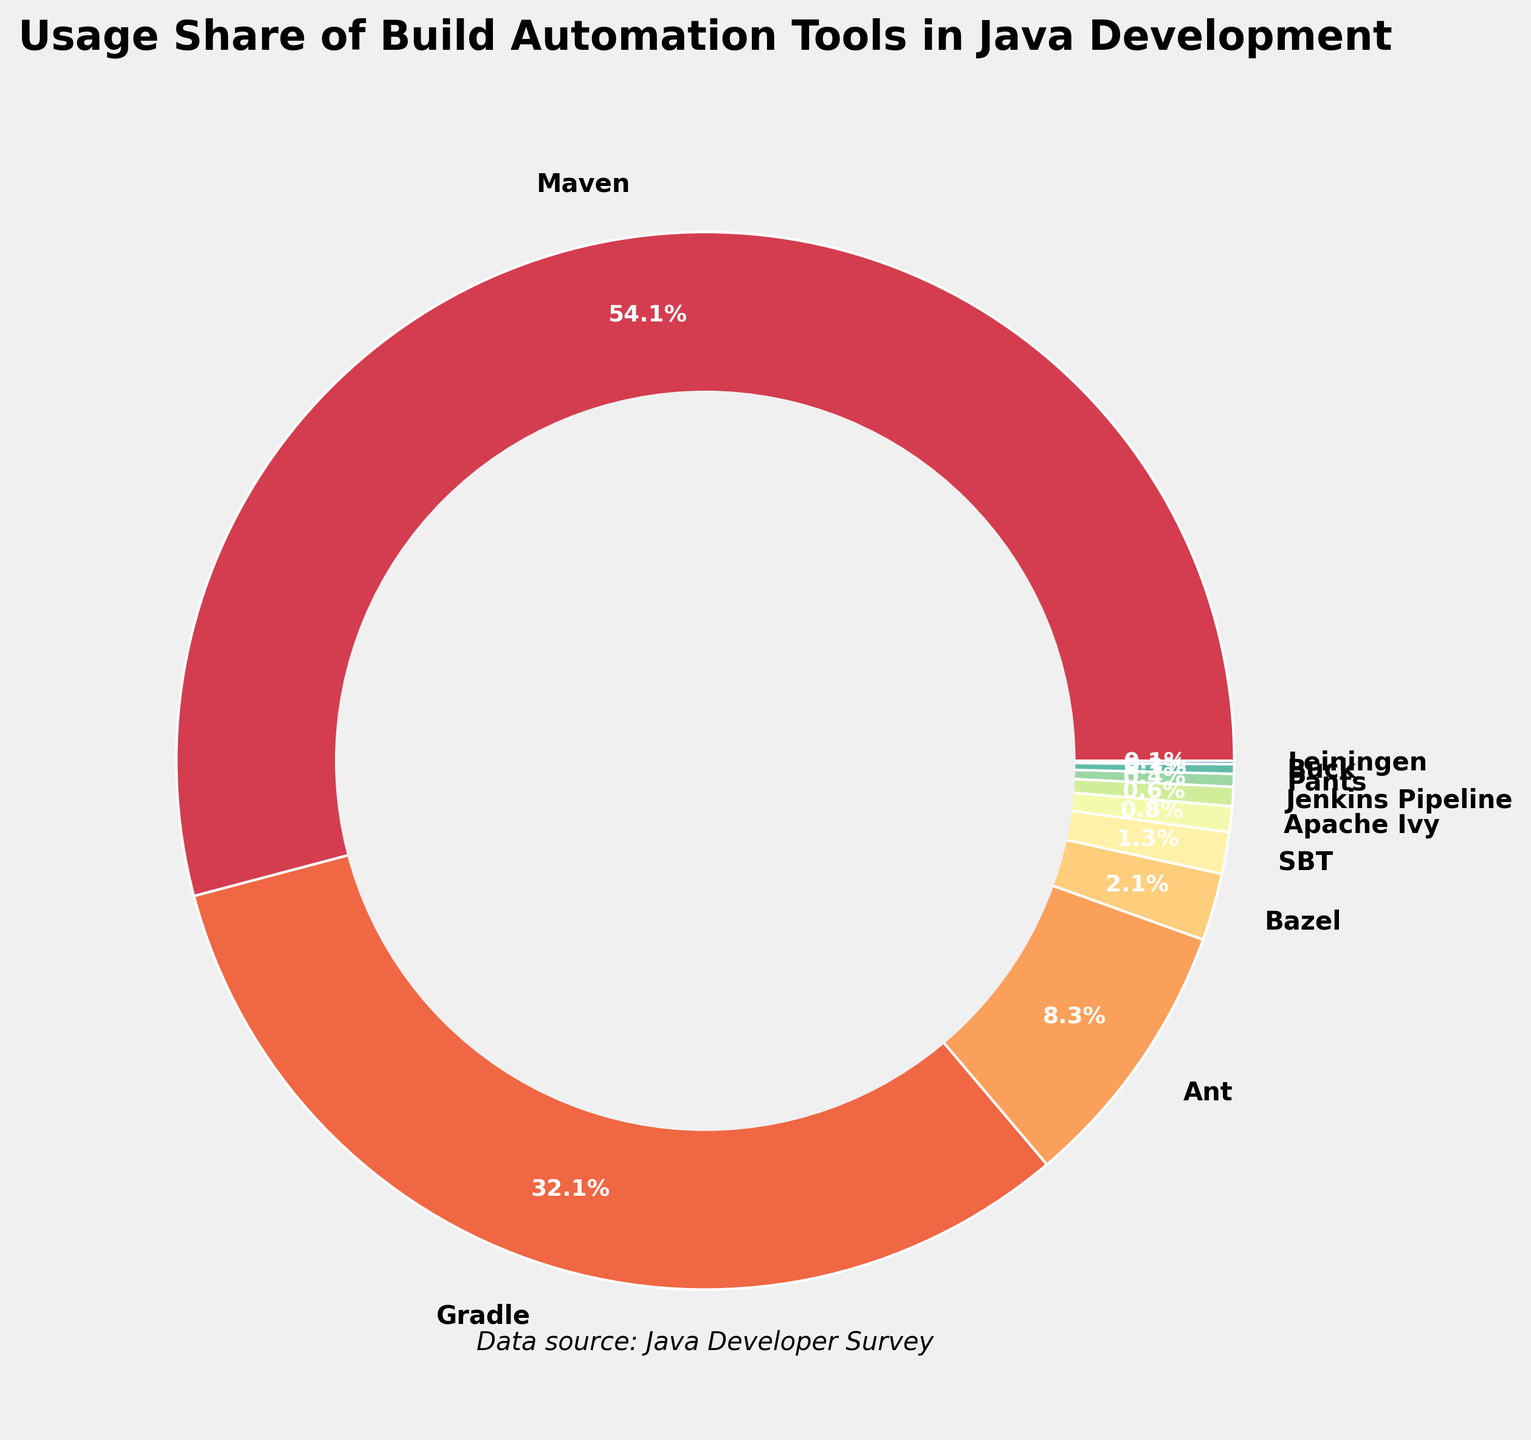What is the usage share of Maven? The pie chart shows the usage share of each build tool, and Maven's share is labeled.
Answer: 55.2% Which build tool has the second-highest usage share? By comparing the usage shares, Gradle has the second-highest share after Maven.
Answer: Gradle How much more popular is Ant compared to Bazel? Ant has a usage share of 8.5% while Bazel has 2.1%. The difference is 8.5% - 2.1% = 6.4%.
Answer: 6.4% What is the combined usage share of Maven, Gradle, and Ant? Adding the usage shares of Maven (55.2%), Gradle (32.7%), and Ant (8.5%), the combined share is 55.2% + 32.7% + 8.5% = 96.4%.
Answer: 96.4% What is the smallest usage share shown, and which tool does it belong to? The smallest usage share labeled is 0.1%, which belongs to Leiningen.
Answer: 0.1%, Leiningen Is the usage share of Bazel greater than 2%? The pie chart shows Bazel with a usage share of 2.1%, which is slightly greater than 2%.
Answer: Yes How many build tools have a usage share of less than 1%? The tools with shares less than 1% are Apache Ivy (0.8%), Jenkins Pipeline (0.6%), Pants (0.4%), Buck (0.3%), and Leiningen (0.1%). That's 5 tools.
Answer: 5 If you combine the usage of SBT and Apache Ivy, what is their total share? SBT has a share of 1.3%, and Apache Ivy has 0.8%. Adding these gives 1.3% + 0.8% = 2.1%.
Answer: 2.1% Does Maven have more than half of the total usage share? Maven's usage share is labeled as 55.2%, which is more than half of 100%.
Answer: Yes Which tool is most similar in usage share to Jenkins Pipeline? Compare all usage shares, and Pants' share (0.4%) is closest to Jenkins Pipeline's 0.6%.
Answer: Pants 